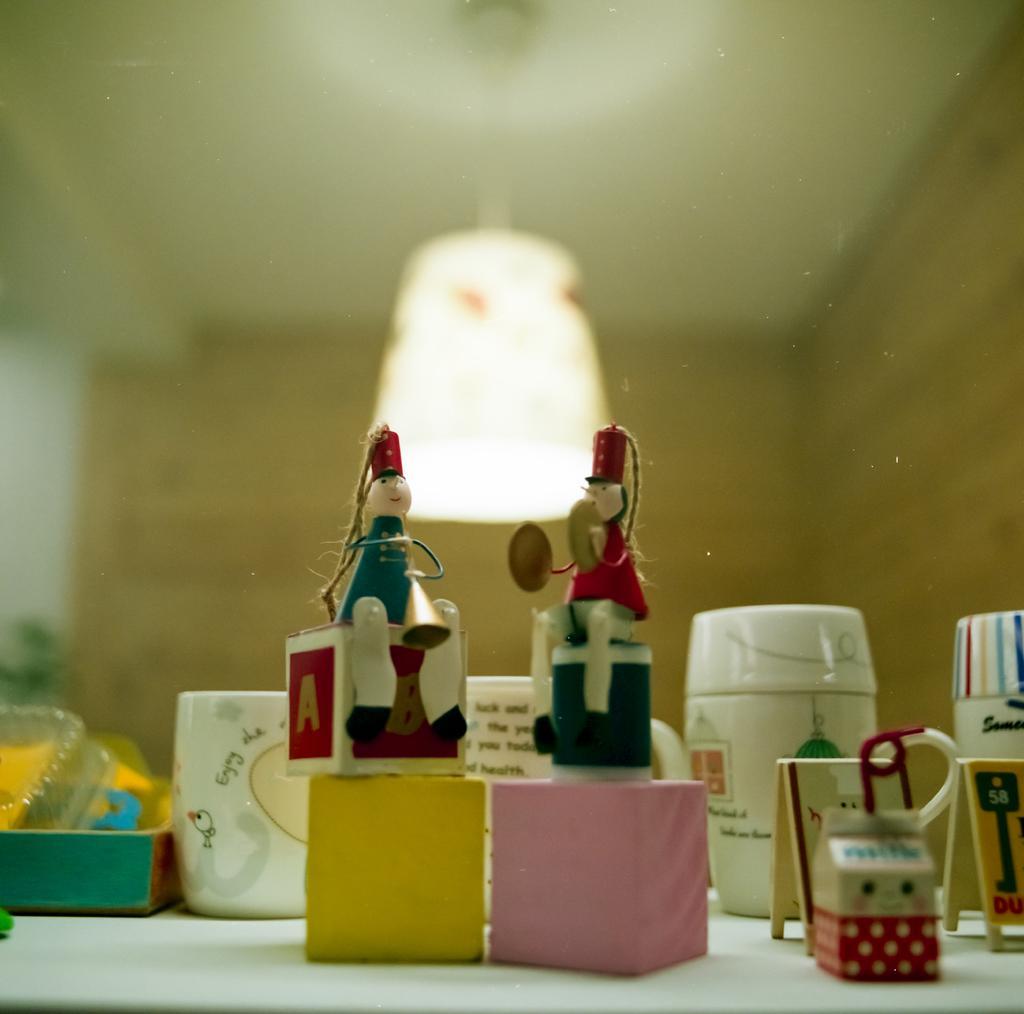Can you describe this image briefly? At the bottom of the image there is a table and we can see blocks, dolls, mugs, box and toys placed on the table. In the background there is a light and a wall. 